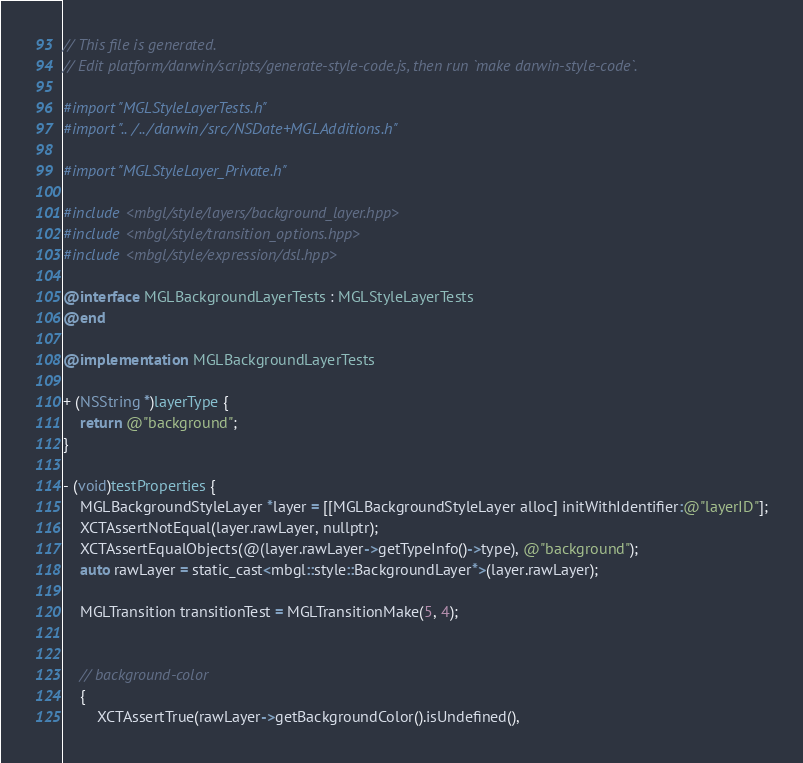Convert code to text. <code><loc_0><loc_0><loc_500><loc_500><_ObjectiveC_>// This file is generated.
// Edit platform/darwin/scripts/generate-style-code.js, then run `make darwin-style-code`.

#import "MGLStyleLayerTests.h"
#import "../../darwin/src/NSDate+MGLAdditions.h"

#import "MGLStyleLayer_Private.h"

#include <mbgl/style/layers/background_layer.hpp>
#include <mbgl/style/transition_options.hpp>
#include <mbgl/style/expression/dsl.hpp>

@interface MGLBackgroundLayerTests : MGLStyleLayerTests
@end

@implementation MGLBackgroundLayerTests

+ (NSString *)layerType {
    return @"background";
}

- (void)testProperties {
    MGLBackgroundStyleLayer *layer = [[MGLBackgroundStyleLayer alloc] initWithIdentifier:@"layerID"];
    XCTAssertNotEqual(layer.rawLayer, nullptr);
    XCTAssertEqualObjects(@(layer.rawLayer->getTypeInfo()->type), @"background");
    auto rawLayer = static_cast<mbgl::style::BackgroundLayer*>(layer.rawLayer);

    MGLTransition transitionTest = MGLTransitionMake(5, 4);


    // background-color
    {
        XCTAssertTrue(rawLayer->getBackgroundColor().isUndefined(),</code> 